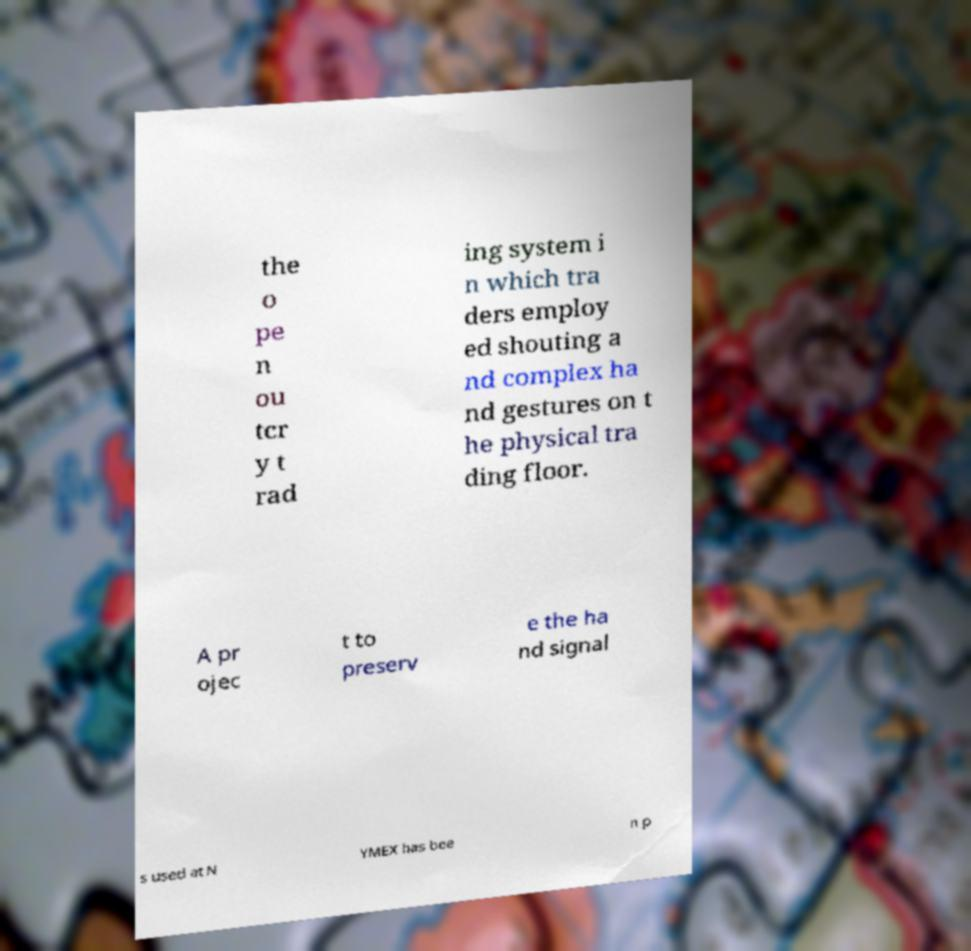Could you extract and type out the text from this image? the o pe n ou tcr y t rad ing system i n which tra ders employ ed shouting a nd complex ha nd gestures on t he physical tra ding floor. A pr ojec t to preserv e the ha nd signal s used at N YMEX has bee n p 